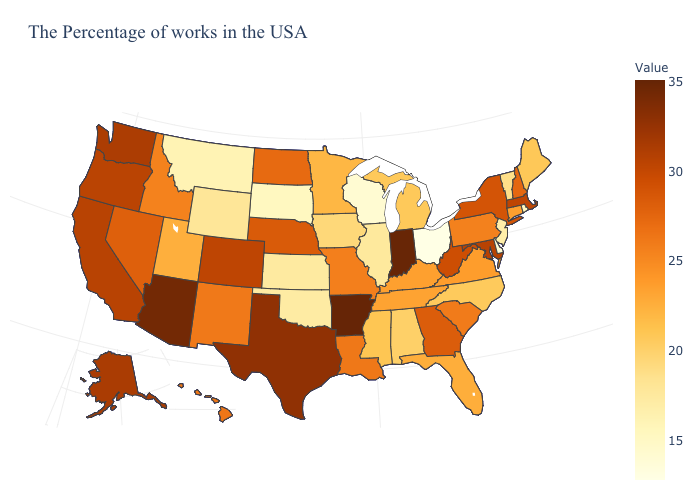Does California have the highest value in the USA?
Write a very short answer. No. Is the legend a continuous bar?
Short answer required. Yes. Does Vermont have the lowest value in the Northeast?
Concise answer only. No. Which states have the lowest value in the USA?
Short answer required. Ohio. Among the states that border Louisiana , which have the highest value?
Keep it brief. Arkansas. Which states hav the highest value in the South?
Answer briefly. Arkansas. Does Mississippi have a higher value than Oklahoma?
Answer briefly. Yes. 